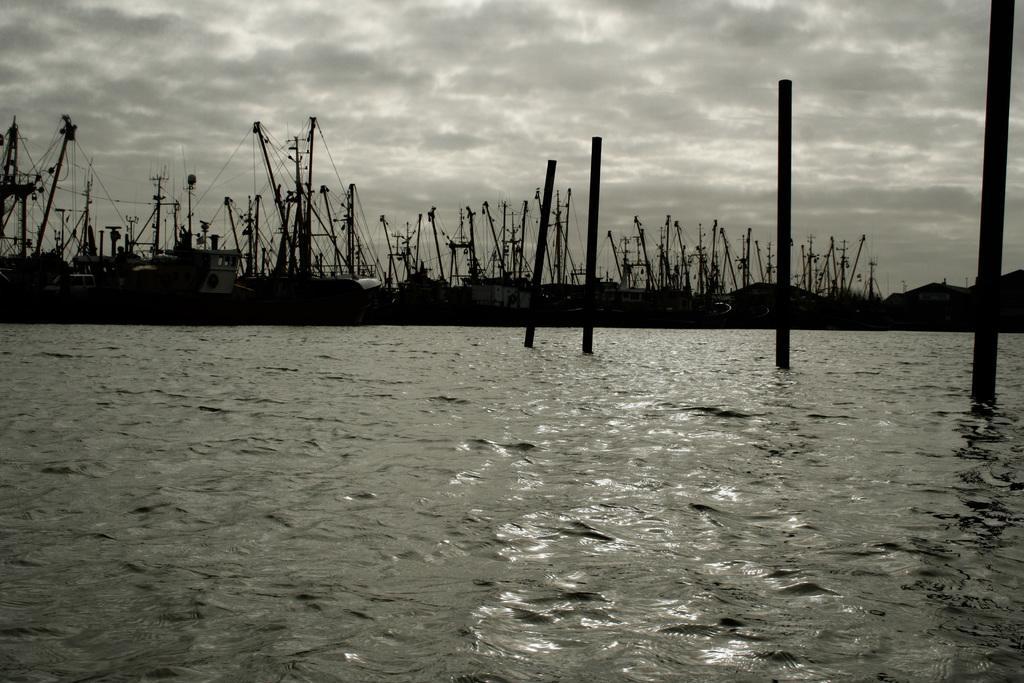In one or two sentences, can you explain what this image depicts? In this image we can see ships and poles on the water. In the background there are clouds and sky. 